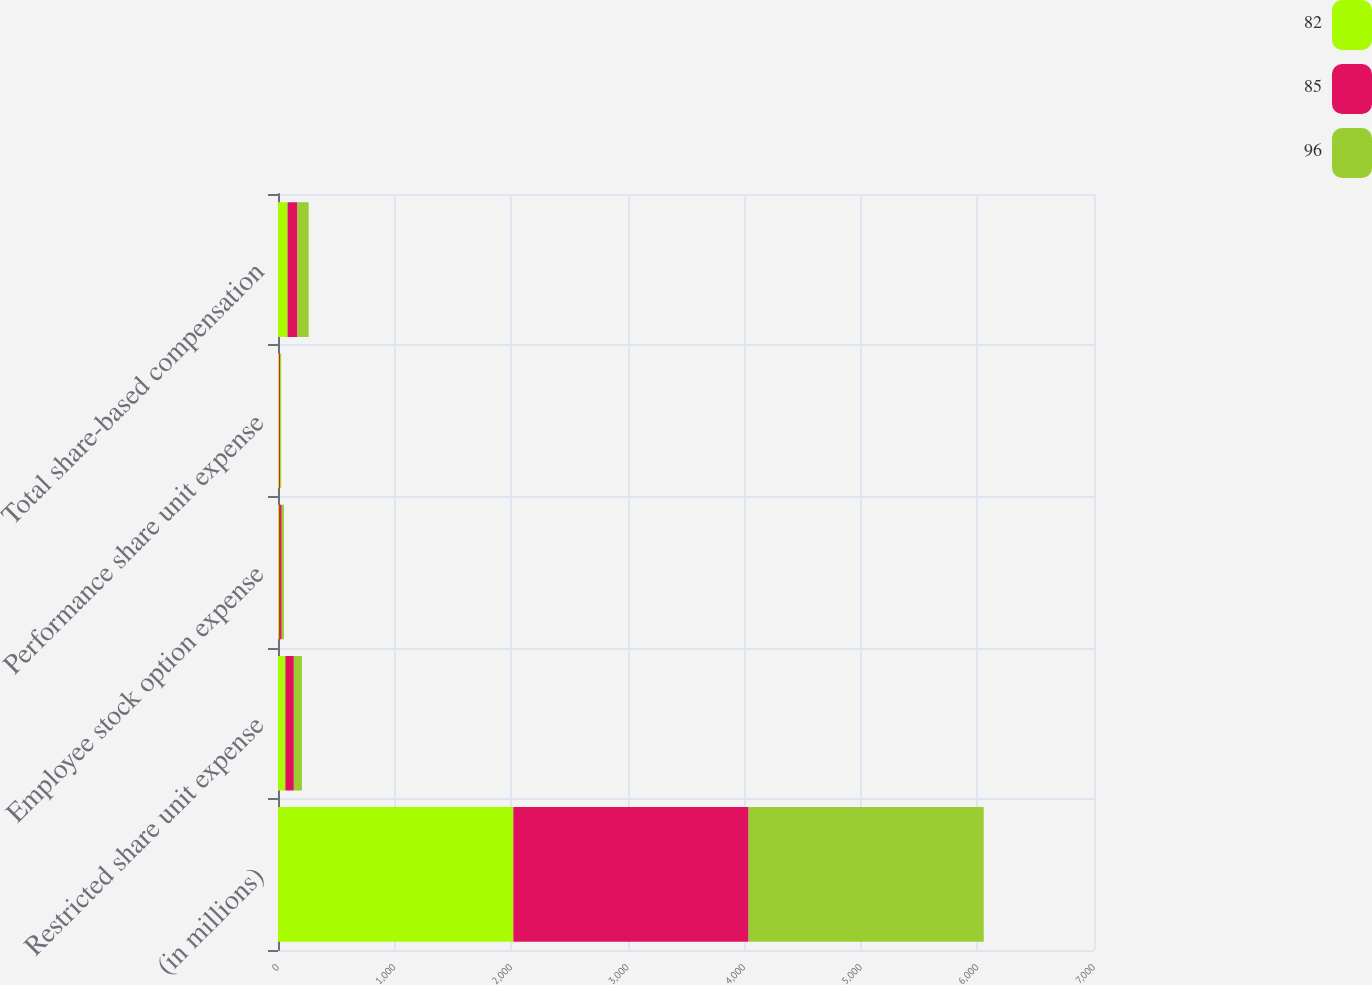Convert chart. <chart><loc_0><loc_0><loc_500><loc_500><stacked_bar_chart><ecel><fcel>(in millions)<fcel>Restricted share unit expense<fcel>Employee stock option expense<fcel>Performance share unit expense<fcel>Total share-based compensation<nl><fcel>82<fcel>2019<fcel>63<fcel>10<fcel>9<fcel>82<nl><fcel>85<fcel>2018<fcel>73<fcel>22<fcel>10<fcel>85<nl><fcel>96<fcel>2017<fcel>69<fcel>19<fcel>8<fcel>96<nl></chart> 